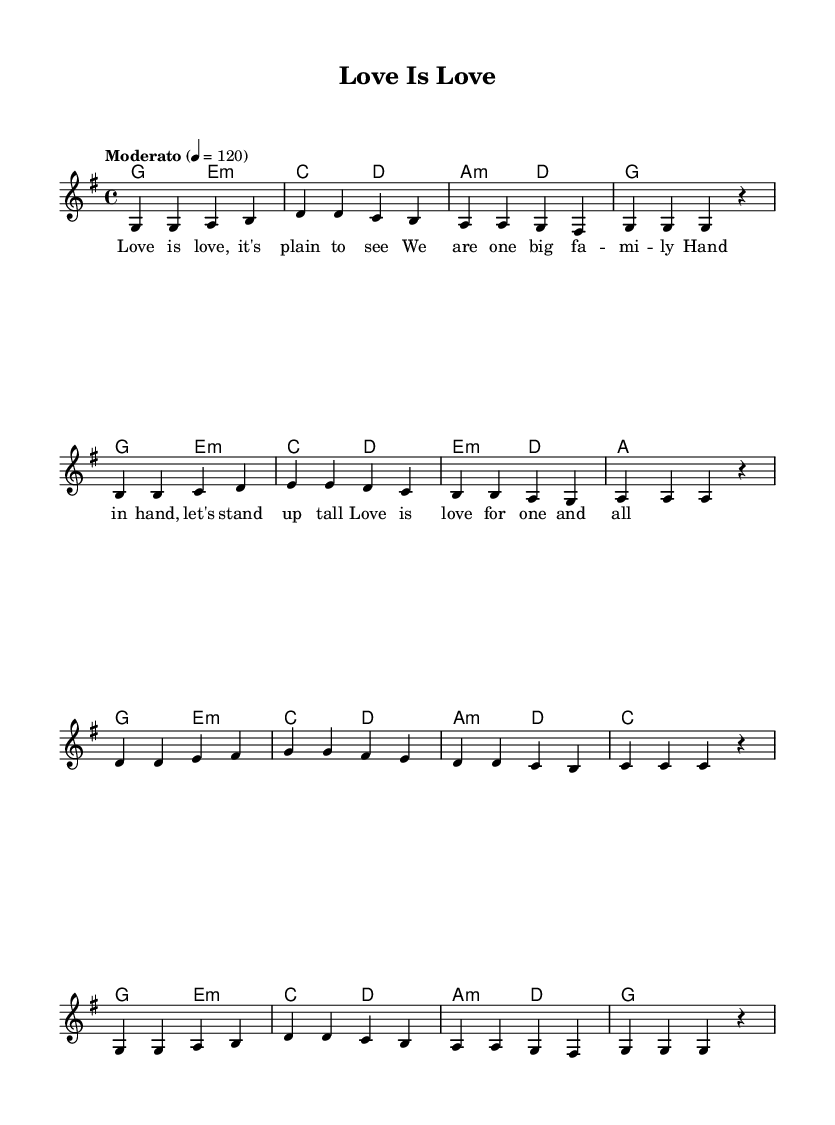What is the key signature of this music? The key signature shows one sharp (F#), indicating that the piece is in G major.
Answer: G major What is the time signature of this music? The time signature is indicated at the beginning of the score as 4/4, meaning there are four beats in each measure.
Answer: 4/4 What is the tempo marking of this piece? The tempo marking states "Moderato" with a metronome marking of 120, indicating a moderate speed.
Answer: Moderato, 120 How many measures are in the melody section? By counting the measures in the melody part, there are 12 measures in total.
Answer: 12 What are the first lyrics of the song? The first lyrics are displayed directly beneath the notes, starting with "Love is love".
Answer: Love is love How many different chords are used in the harmony section? Analyzing the harmony section reveals that there are six unique chord types: G, E minor, C, D, A minor, and E minor (which appears twice but is still one type).
Answer: 6 Which voice is indicated in the staff? The staff is labeled as "melody," indicating that it contains the vocal melody line.
Answer: melody 